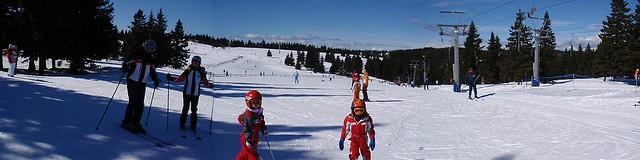What are the metal towers used for? ski lift 